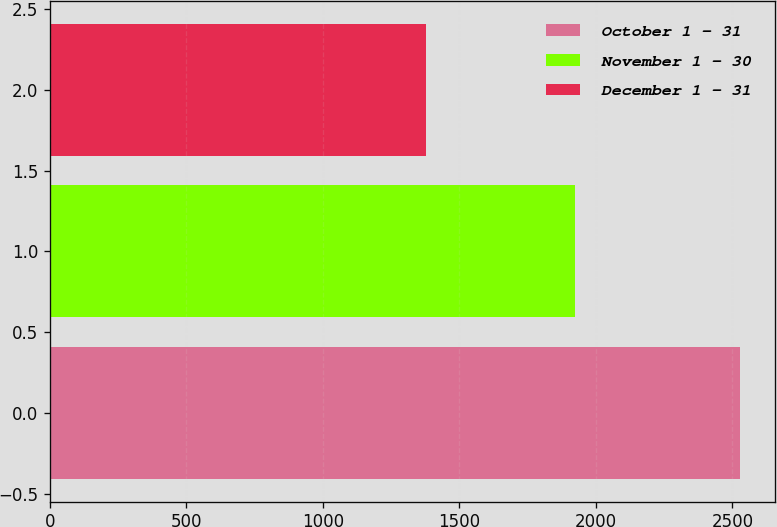Convert chart to OTSL. <chart><loc_0><loc_0><loc_500><loc_500><bar_chart><fcel>October 1 - 31<fcel>November 1 - 30<fcel>December 1 - 31<nl><fcel>2528<fcel>1923<fcel>1379<nl></chart> 